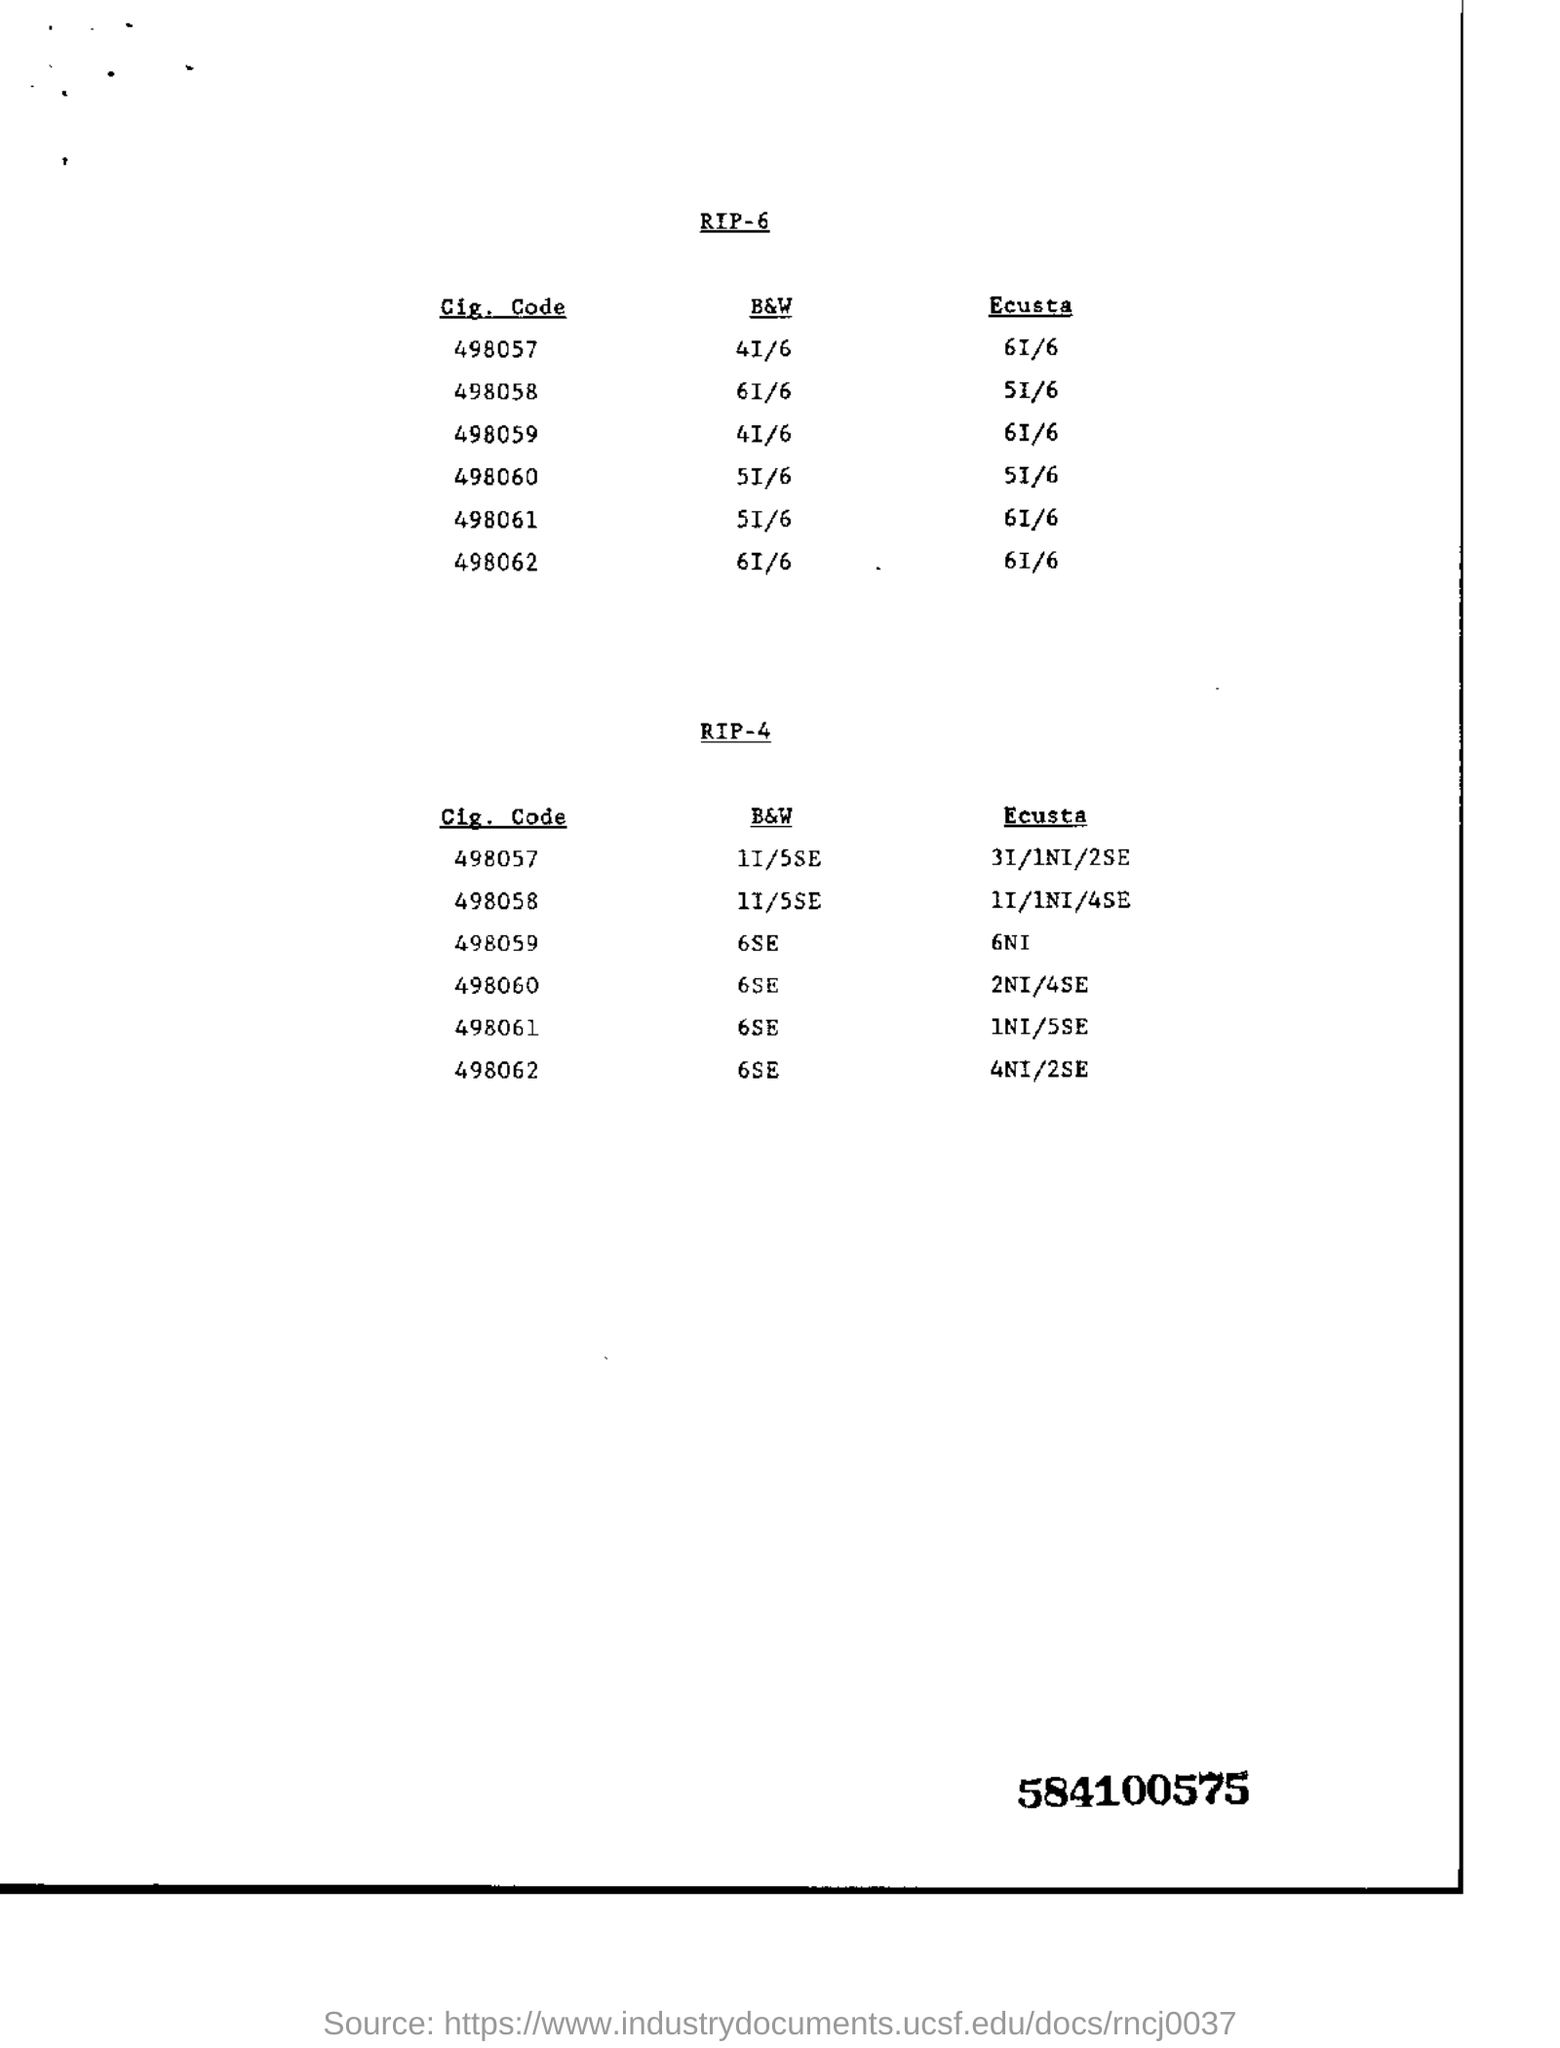What is the Ecusta of Cig. Code 498062 mentioned in RIP-6?
Ensure brevity in your answer.  6I/6. What is the 9 digits number mentioned in bold?
Keep it short and to the point. 584100575. Cig. Code 498062 and B&W 6SE  is mentioned in which RIP?
Provide a short and direct response. RIP-4. 